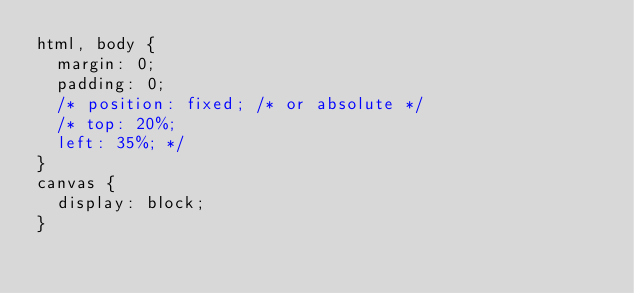Convert code to text. <code><loc_0><loc_0><loc_500><loc_500><_CSS_>html, body {
  margin: 0;
  padding: 0;
  /* position: fixed; /* or absolute */ 
  /* top: 20%;
  left: 35%; */
}
canvas {
  display: block;
}
</code> 